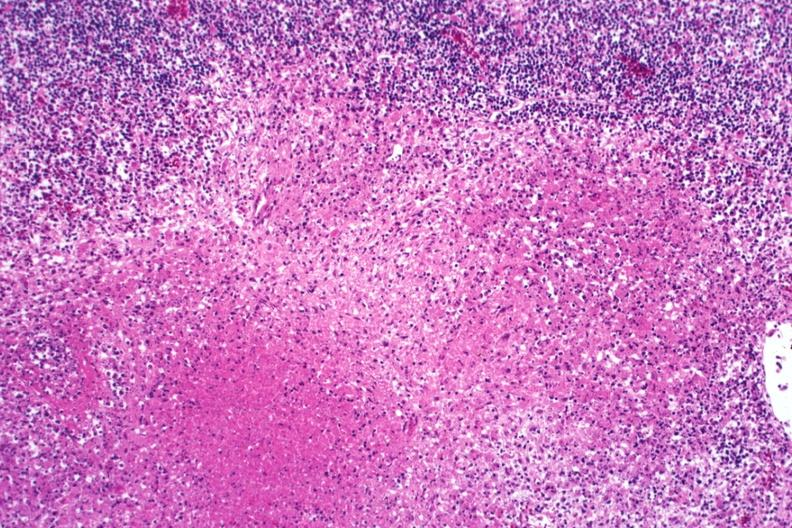what does this image show?
Answer the question using a single word or phrase. Typical necrotizing granulomas 